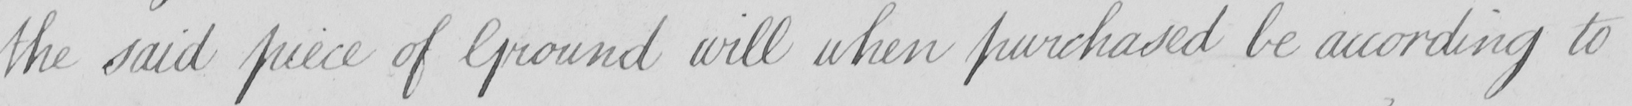What is written in this line of handwriting? the said piece of Ground will when purchased be according to 